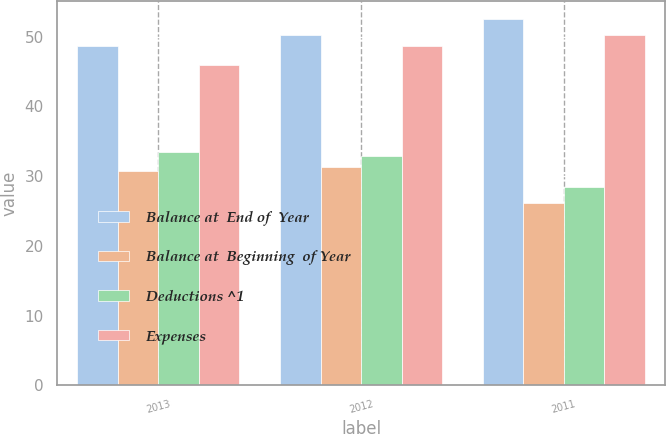<chart> <loc_0><loc_0><loc_500><loc_500><stacked_bar_chart><ecel><fcel>2013<fcel>2012<fcel>2011<nl><fcel>Balance at  End of  Year<fcel>48.7<fcel>50.3<fcel>52.5<nl><fcel>Balance at  Beginning  of Year<fcel>30.7<fcel>31.3<fcel>26.2<nl><fcel>Deductions ^1<fcel>33.4<fcel>32.9<fcel>28.4<nl><fcel>Expenses<fcel>46<fcel>48.7<fcel>50.3<nl></chart> 